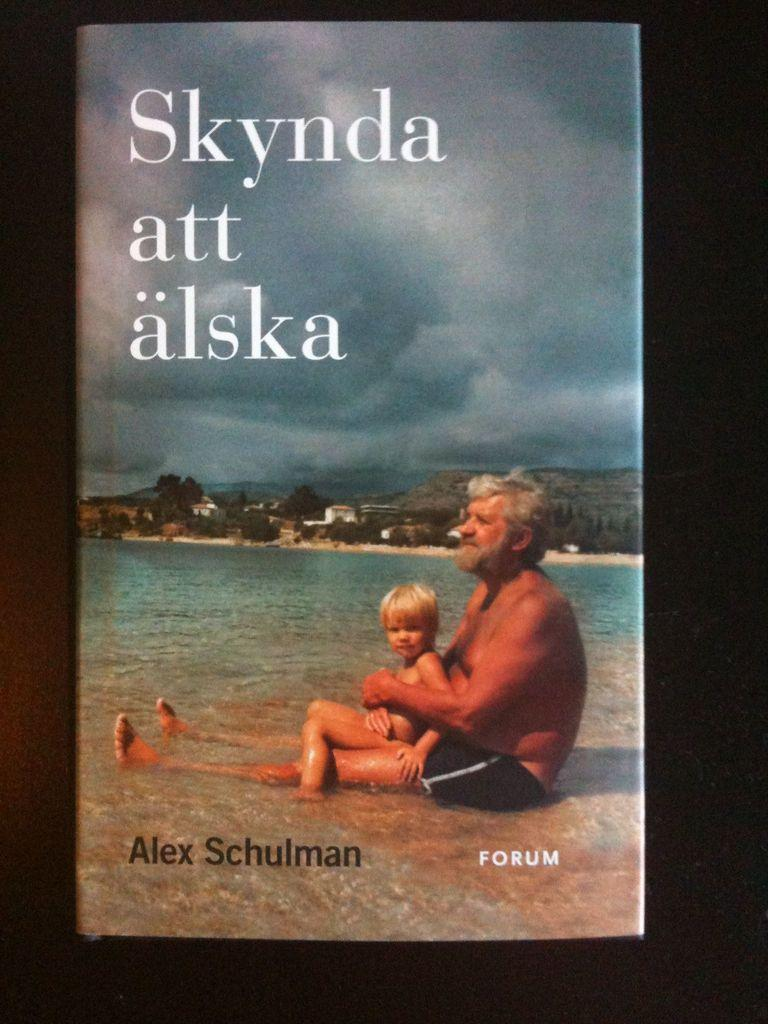Provide a one-sentence caption for the provided image. an ad of a man and son in the ocean saying "Skynda att alska". 